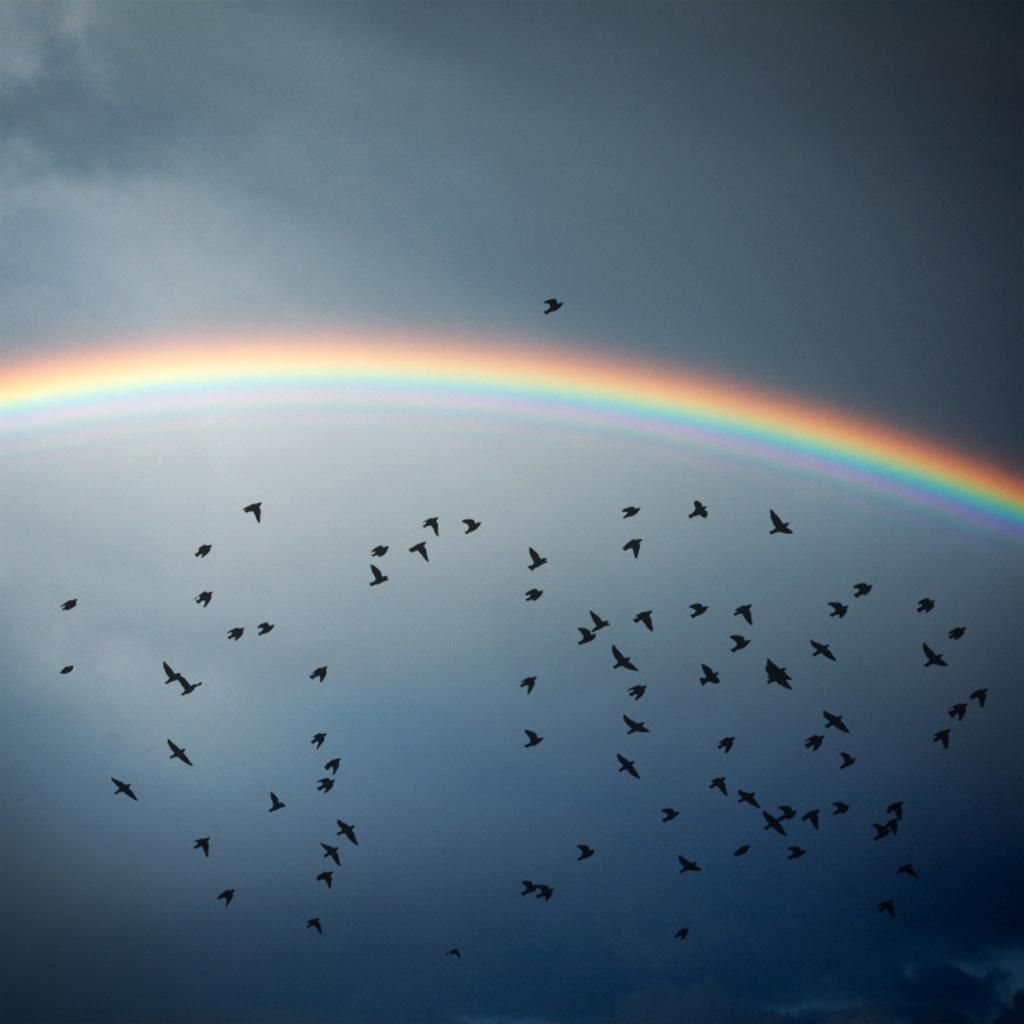What is happening in the sky in the image? There are birds flying in the air in the image. What can be seen above the birds in the sky? There is a rainbow visible above the birds in the image. What type of potato is being used as a detail in the image? There is no potato present in the image, and therefore no such detail can be observed. 